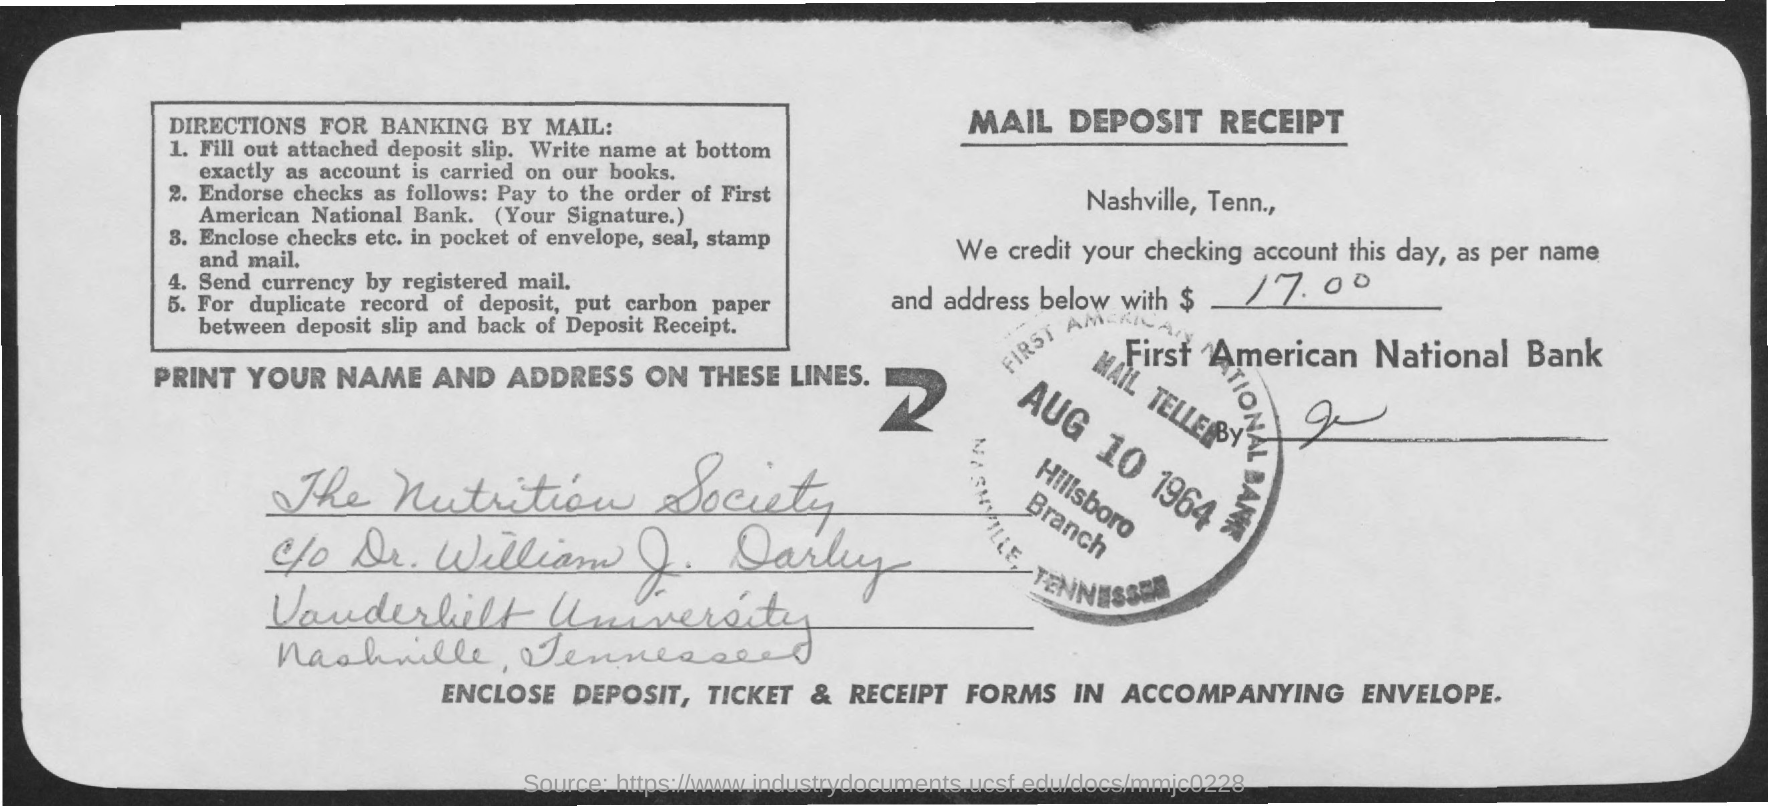What is the amount credited as mentioned in the mail deposit receipt?
Your answer should be compact. $ 17.00. What type of receipt is given here?
Your answer should be compact. MAIL DEPOSIT RECEIPT. 